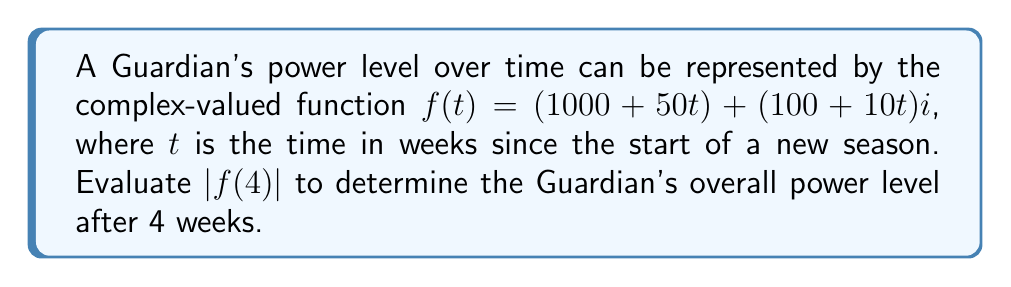Show me your answer to this math problem. To solve this problem, we'll follow these steps:

1) The given function is $f(t) = (1000 + 50t) + (100 + 10t)i$

2) We need to evaluate $|f(4)|$, which means we'll substitute $t=4$ into the function:

   $f(4) = (1000 + 50(4)) + (100 + 10(4))i$
   $f(4) = (1000 + 200) + (100 + 40)i$
   $f(4) = 1200 + 140i$

3) To find $|f(4)|$, we need to calculate the modulus of this complex number. For a complex number $a + bi$, the modulus is given by $\sqrt{a^2 + b^2}$.

4) In this case, $a = 1200$ and $b = 140$. Let's substitute these into the formula:

   $|f(4)| = \sqrt{1200^2 + 140^2}$

5) Now, let's calculate:
   
   $|f(4)| = \sqrt{1,440,000 + 19,600}$
   $|f(4)| = \sqrt{1,459,600}$

6) Simplify:
   
   $|f(4)| = 1,208.14$ (rounded to two decimal places)

This result represents the Guardian's overall power level after 4 weeks.
Answer: $|f(4)| = 1,208.14$ 